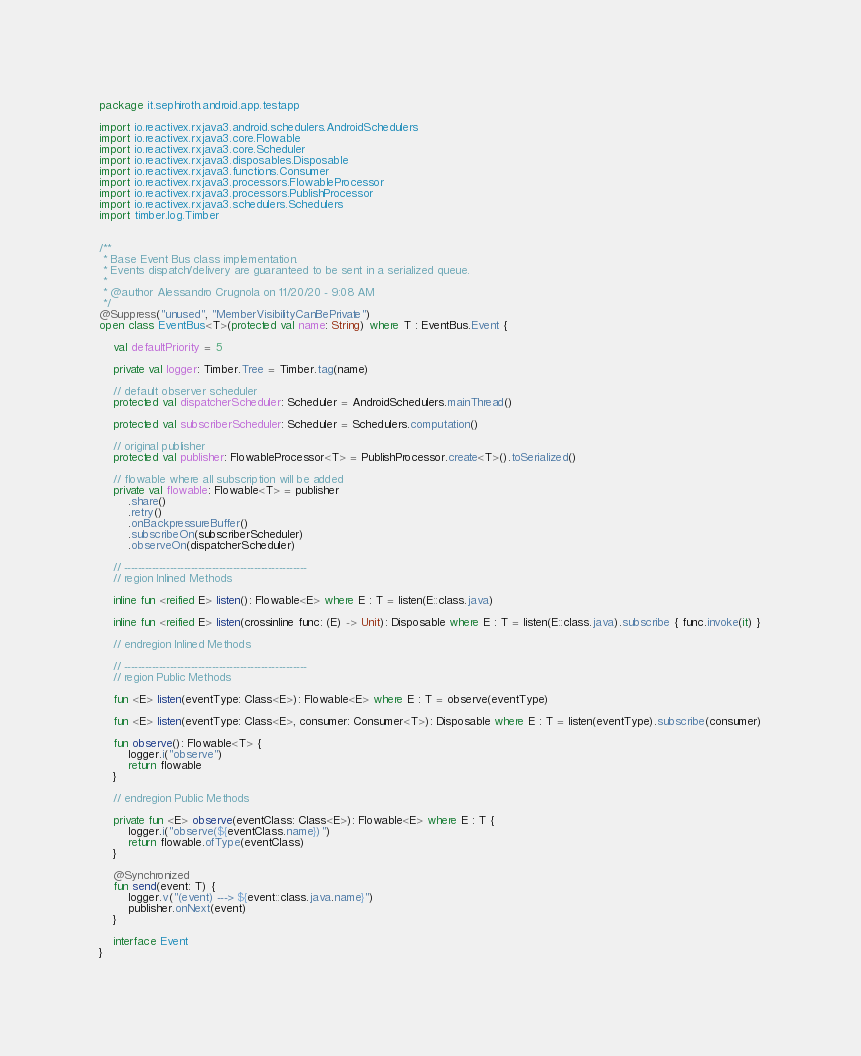<code> <loc_0><loc_0><loc_500><loc_500><_Kotlin_>package it.sephiroth.android.app.testapp

import io.reactivex.rxjava3.android.schedulers.AndroidSchedulers
import io.reactivex.rxjava3.core.Flowable
import io.reactivex.rxjava3.core.Scheduler
import io.reactivex.rxjava3.disposables.Disposable
import io.reactivex.rxjava3.functions.Consumer
import io.reactivex.rxjava3.processors.FlowableProcessor
import io.reactivex.rxjava3.processors.PublishProcessor
import io.reactivex.rxjava3.schedulers.Schedulers
import timber.log.Timber


/**
 * Base Event Bus class implementation.
 * Events dispatch/delivery are guaranteed to be sent in a serialized queue.
 *
 * @author Alessandro Crugnola on 11/20/20 - 9:08 AM
 */
@Suppress("unused", "MemberVisibilityCanBePrivate")
open class EventBus<T>(protected val name: String) where T : EventBus.Event {

    val defaultPriority = 5

    private val logger: Timber.Tree = Timber.tag(name)

    // default observer scheduler
    protected val dispatcherScheduler: Scheduler = AndroidSchedulers.mainThread()

    protected val subscriberScheduler: Scheduler = Schedulers.computation()

    // original publisher
    protected val publisher: FlowableProcessor<T> = PublishProcessor.create<T>().toSerialized()

    // flowable where all subscription will be added
    private val flowable: Flowable<T> = publisher
        .share()
        .retry()
        .onBackpressureBuffer()
        .subscribeOn(subscriberScheduler)
        .observeOn(dispatcherScheduler)

    // ----------------------------------------------------
    // region Inlined Methods

    inline fun <reified E> listen(): Flowable<E> where E : T = listen(E::class.java)

    inline fun <reified E> listen(crossinline func: (E) -> Unit): Disposable where E : T = listen(E::class.java).subscribe { func.invoke(it) }

    // endregion Inlined Methods

    // ----------------------------------------------------
    // region Public Methods

    fun <E> listen(eventType: Class<E>): Flowable<E> where E : T = observe(eventType)

    fun <E> listen(eventType: Class<E>, consumer: Consumer<T>): Disposable where E : T = listen(eventType).subscribe(consumer)

    fun observe(): Flowable<T> {
        logger.i("observe")
        return flowable
    }

    // endregion Public Methods

    private fun <E> observe(eventClass: Class<E>): Flowable<E> where E : T {
        logger.i("observe(${eventClass.name})")
        return flowable.ofType(eventClass)
    }

    @Synchronized
    fun send(event: T) {
        logger.v("(event) ---> ${event::class.java.name}")
        publisher.onNext(event)
    }

    interface Event
}

</code> 